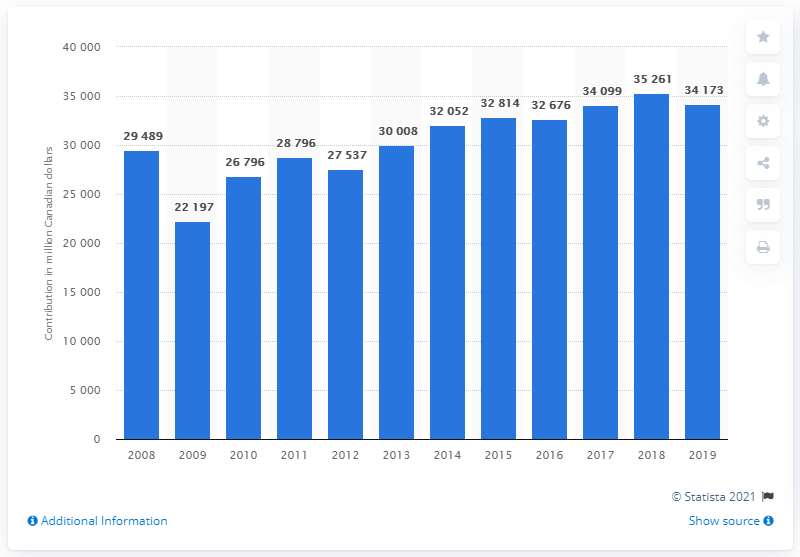Specify some key components in this picture. In 2019, the mining industry contributed a significant amount to Canada's Gross Domestic Product (GDP), estimated to be 34,173. In 2009, mining contributed approximately 2.2% of Canada's real GDP. 